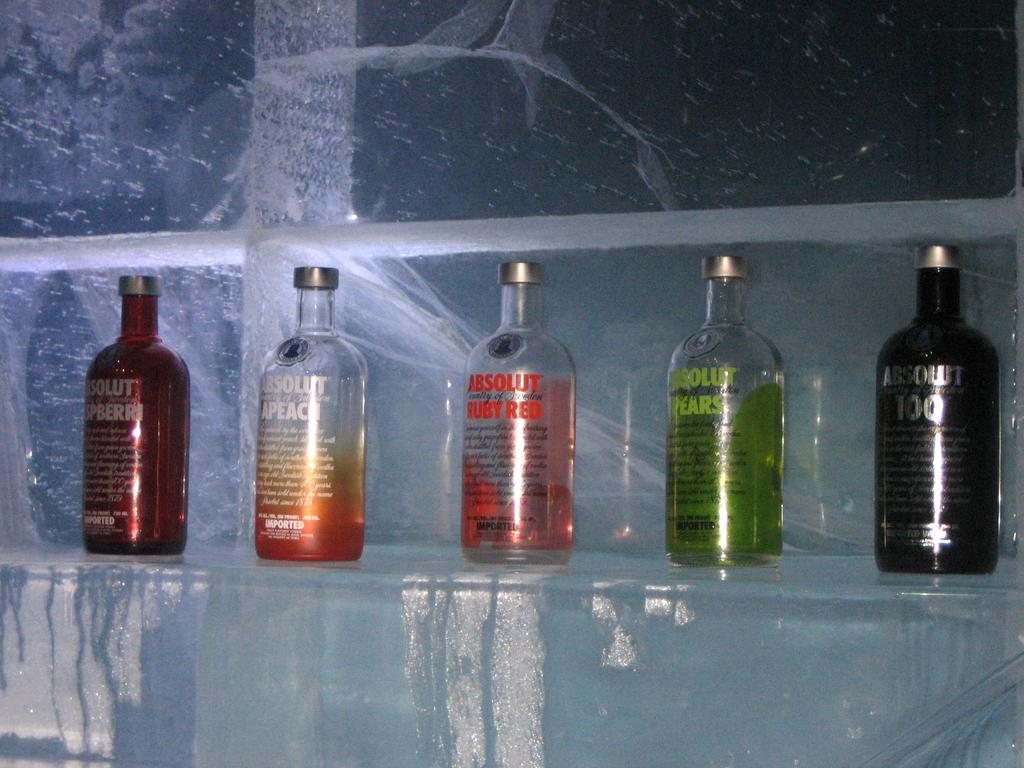<image>
Present a compact description of the photo's key features. Five bottles of Absolute Vokda are on an icy shelf. 